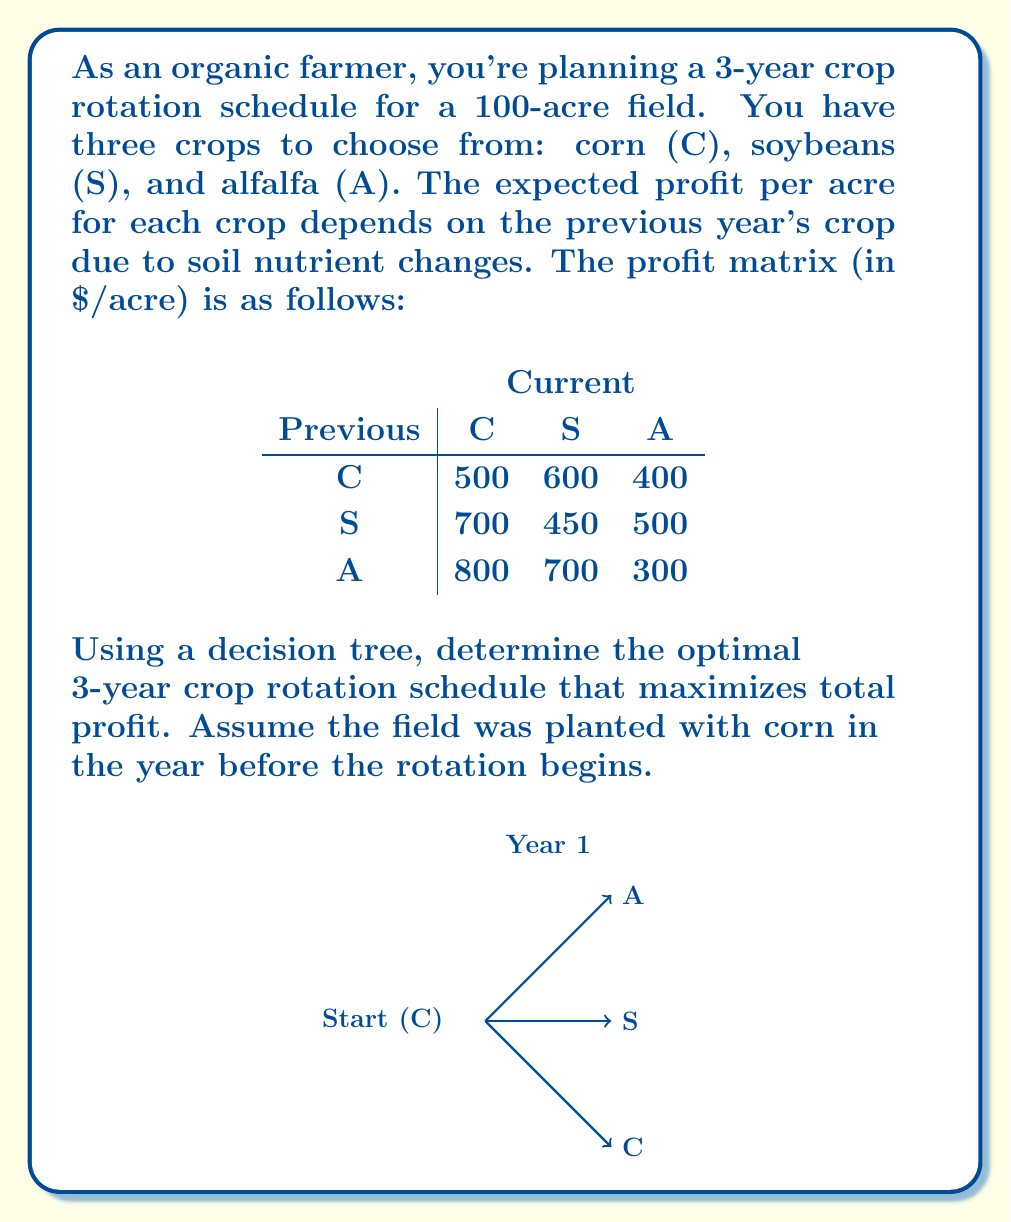Could you help me with this problem? Let's solve this problem using a decision tree and backward induction:

1) First, we'll construct the decision tree for the 3-year period. Each level represents a year, and each branch represents a crop choice.

2) We'll start from the last year (Year 3) and work backwards:

   Year 3: For each possible Year 2 crop, calculate the profit for each Year 3 crop choice.
   Year 2: For each Year 1 crop, choose the most profitable Year 3 crop and sum the profits.
   Year 1: Choose the most profitable path starting from corn.

3) Year 3 calculations (profit per acre):
   If Year 2 was C: C=$500, S=$600, A=$400
   If Year 2 was S: C=$700, S=$450, A=$500
   If Year 2 was A: C=$800, S=$700, A=$300

4) Year 2 calculations (cumulative profit per acre):
   If Year 1 was C:
     C → max(500,600,400) = 600 (S), Total = 500+600 = $1100
     S → max(700,450,500) = 700 (C), Total = 600+700 = $1300
     A → max(800,700,300) = 800 (C), Total = 400+800 = $1200
   
   If Year 1 was S:
     C → max(500,600,400) = 600 (S), Total = 700+600 = $1300
     S → max(700,450,500) = 700 (C), Total = 450+700 = $1150
     A → max(800,700,300) = 800 (C), Total = 500+800 = $1300
   
   If Year 1 was A:
     C → max(500,600,400) = 600 (S), Total = 800+600 = $1400
     S → max(700,450,500) = 700 (C), Total = 700+700 = $1400
     A → max(800,700,300) = 800 (C), Total = 300+800 = $1100

5) Year 1 decision (starting from corn):
   C → max(1100,1300,1200) = $1300 (S path)
   S → max(1300,1150,1300) = $1300 (C or A path)
   A → max(1400,1400,1100) = $1400 (C or S path)

6) The optimal path is C (given) → A → C, with a total profit of $800 + $800 = $1600 per acre.

7) For the entire 100-acre field, the total profit would be:
   $1600/acre × 100 acres = $160,000
Answer: Optimal rotation: Corn → Alfalfa → Corn; Total profit: $160,000 